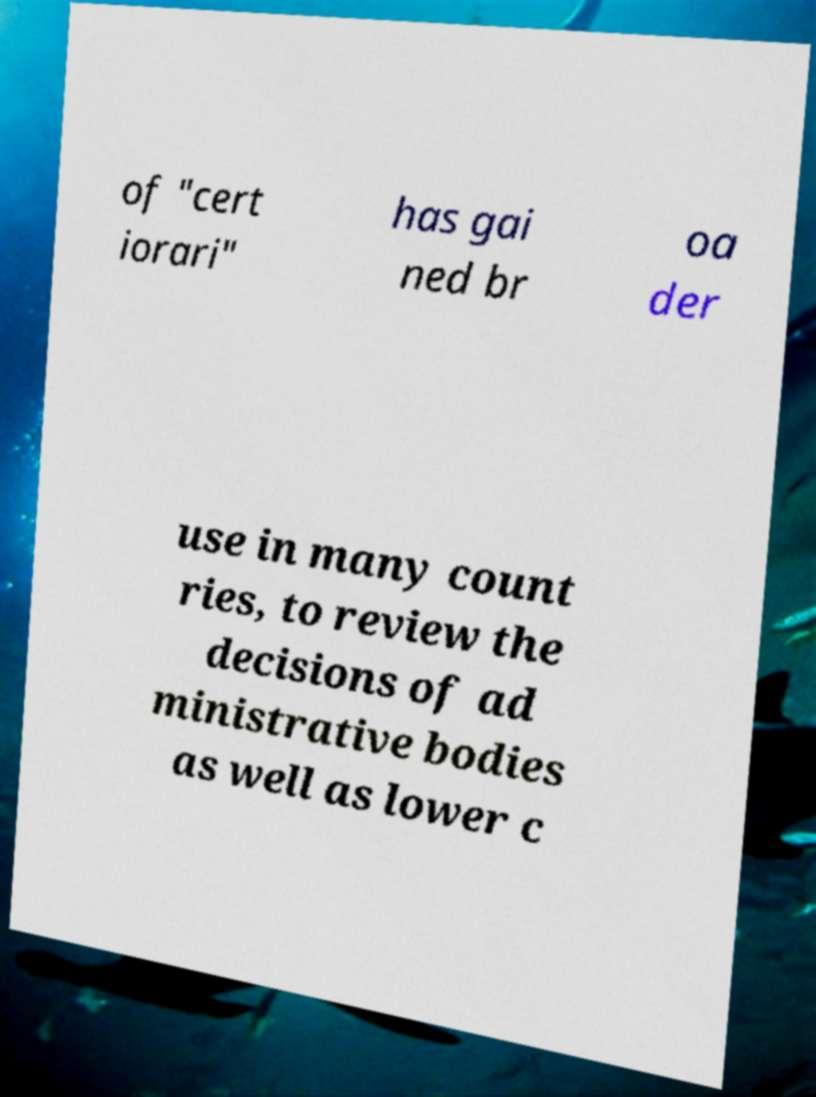What messages or text are displayed in this image? I need them in a readable, typed format. of "cert iorari" has gai ned br oa der use in many count ries, to review the decisions of ad ministrative bodies as well as lower c 